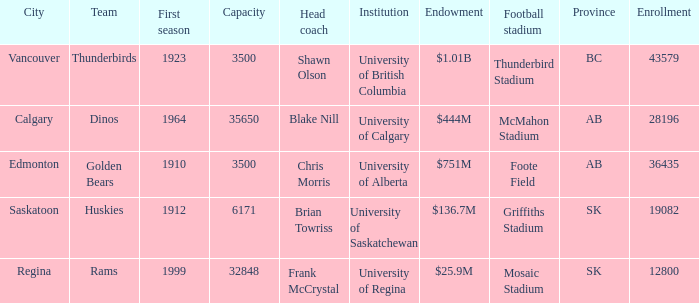How many cities have an enrollment of 19082? 1.0. 